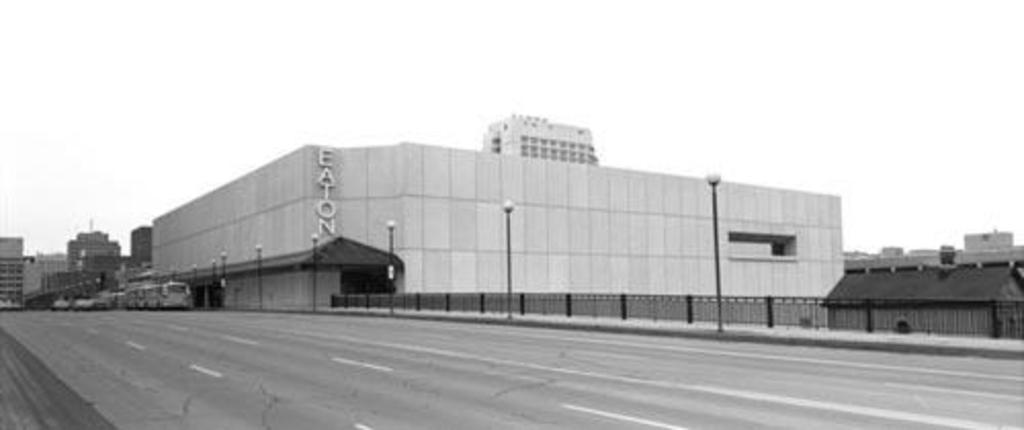What can be seen on the road in the image? There are vehicles on the road in the image. What is located beside the vehicles? There is a fence beside the vehicles. What structures are present in the image? There are poles and buildings in the image. What can be seen illuminating the area in the image? There are lights in the image. Where is the patch of grass located in the image? There is no patch of grass present in the image. What type of spider web can be seen in the image? There are no spider webs, including cobwebs, present in the image. 